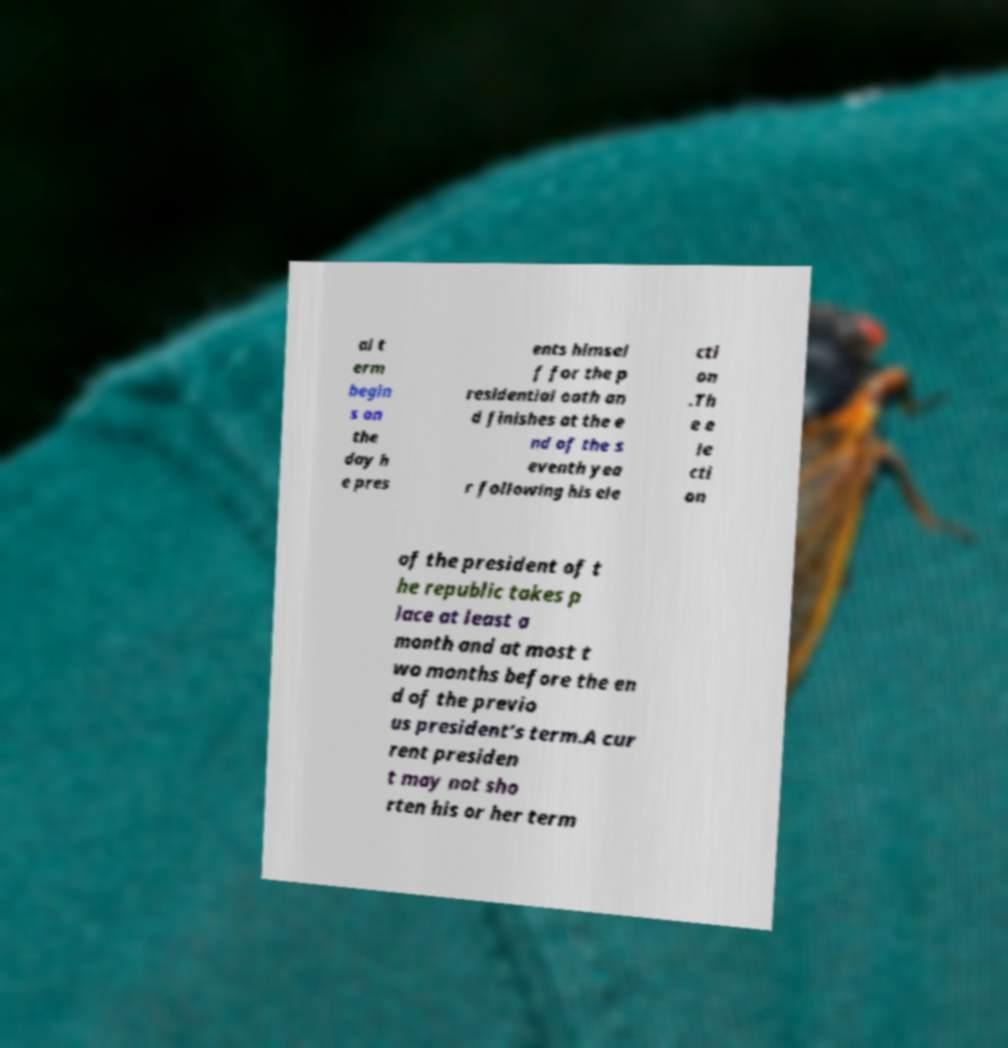Please read and relay the text visible in this image. What does it say? al t erm begin s on the day h e pres ents himsel f for the p residential oath an d finishes at the e nd of the s eventh yea r following his ele cti on .Th e e le cti on of the president of t he republic takes p lace at least a month and at most t wo months before the en d of the previo us president’s term.A cur rent presiden t may not sho rten his or her term 